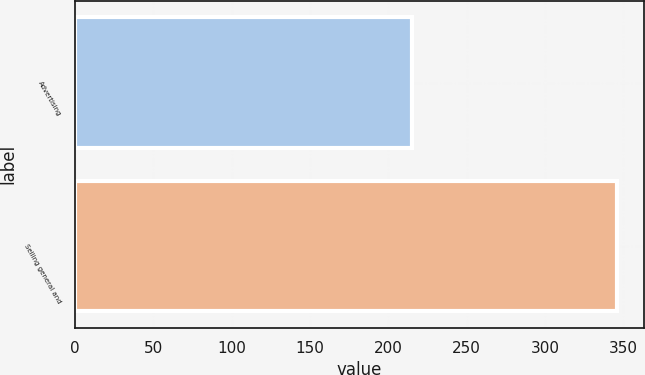Convert chart to OTSL. <chart><loc_0><loc_0><loc_500><loc_500><bar_chart><fcel>Advertising<fcel>Selling general and<nl><fcel>215<fcel>346<nl></chart> 